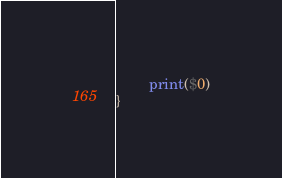Convert code to text. <code><loc_0><loc_0><loc_500><loc_500><_Awk_>        print($0)
}

</code> 